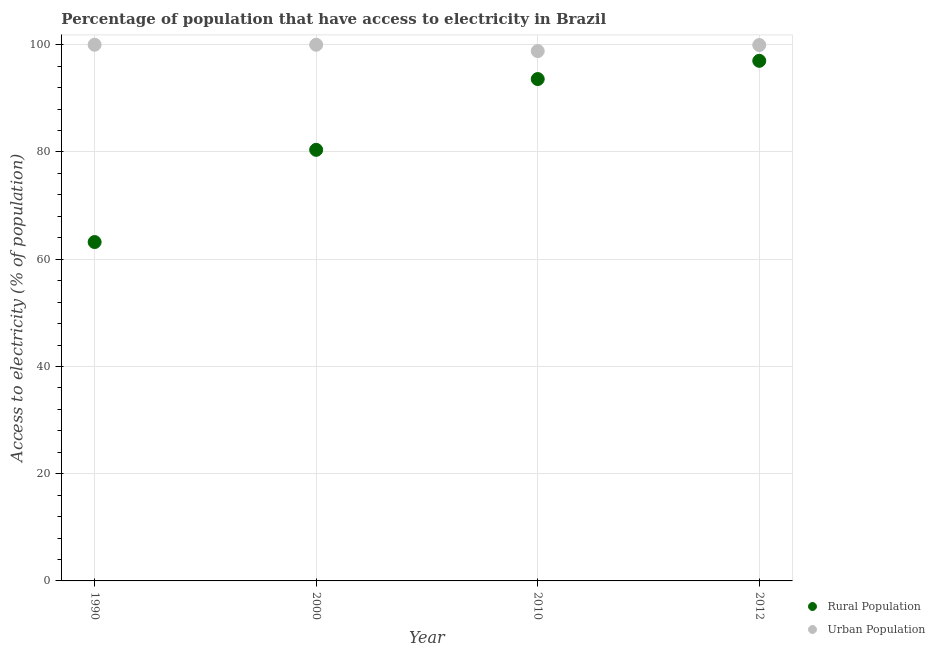How many different coloured dotlines are there?
Provide a succinct answer. 2. Is the number of dotlines equal to the number of legend labels?
Give a very brief answer. Yes. What is the percentage of rural population having access to electricity in 2000?
Your answer should be very brief. 80.4. Across all years, what is the minimum percentage of urban population having access to electricity?
Provide a succinct answer. 98.82. What is the total percentage of urban population having access to electricity in the graph?
Your response must be concise. 398.76. What is the difference between the percentage of urban population having access to electricity in 2000 and that in 2012?
Keep it short and to the point. 0.05. What is the difference between the percentage of rural population having access to electricity in 2010 and the percentage of urban population having access to electricity in 1990?
Give a very brief answer. -6.4. What is the average percentage of rural population having access to electricity per year?
Your response must be concise. 83.55. In the year 2000, what is the difference between the percentage of urban population having access to electricity and percentage of rural population having access to electricity?
Provide a short and direct response. 19.6. In how many years, is the percentage of rural population having access to electricity greater than 76 %?
Ensure brevity in your answer.  3. Is the percentage of urban population having access to electricity in 2000 less than that in 2012?
Make the answer very short. No. Is the difference between the percentage of urban population having access to electricity in 1990 and 2000 greater than the difference between the percentage of rural population having access to electricity in 1990 and 2000?
Make the answer very short. Yes. What is the difference between the highest and the second highest percentage of rural population having access to electricity?
Provide a short and direct response. 3.4. What is the difference between the highest and the lowest percentage of urban population having access to electricity?
Offer a terse response. 1.18. Does the percentage of rural population having access to electricity monotonically increase over the years?
Ensure brevity in your answer.  Yes. Is the percentage of rural population having access to electricity strictly less than the percentage of urban population having access to electricity over the years?
Your answer should be compact. Yes. What is the difference between two consecutive major ticks on the Y-axis?
Ensure brevity in your answer.  20. Are the values on the major ticks of Y-axis written in scientific E-notation?
Your response must be concise. No. Does the graph contain any zero values?
Your answer should be very brief. No. Does the graph contain grids?
Your response must be concise. Yes. Where does the legend appear in the graph?
Provide a succinct answer. Bottom right. How many legend labels are there?
Provide a succinct answer. 2. What is the title of the graph?
Keep it short and to the point. Percentage of population that have access to electricity in Brazil. What is the label or title of the Y-axis?
Ensure brevity in your answer.  Access to electricity (% of population). What is the Access to electricity (% of population) of Rural Population in 1990?
Keep it short and to the point. 63.2. What is the Access to electricity (% of population) of Rural Population in 2000?
Offer a terse response. 80.4. What is the Access to electricity (% of population) in Rural Population in 2010?
Provide a succinct answer. 93.6. What is the Access to electricity (% of population) in Urban Population in 2010?
Keep it short and to the point. 98.82. What is the Access to electricity (% of population) in Rural Population in 2012?
Your response must be concise. 97. What is the Access to electricity (% of population) in Urban Population in 2012?
Give a very brief answer. 99.95. Across all years, what is the maximum Access to electricity (% of population) of Rural Population?
Give a very brief answer. 97. Across all years, what is the maximum Access to electricity (% of population) in Urban Population?
Offer a terse response. 100. Across all years, what is the minimum Access to electricity (% of population) in Rural Population?
Your response must be concise. 63.2. Across all years, what is the minimum Access to electricity (% of population) in Urban Population?
Your answer should be very brief. 98.82. What is the total Access to electricity (% of population) in Rural Population in the graph?
Offer a terse response. 334.2. What is the total Access to electricity (% of population) in Urban Population in the graph?
Ensure brevity in your answer.  398.76. What is the difference between the Access to electricity (% of population) of Rural Population in 1990 and that in 2000?
Your answer should be very brief. -17.2. What is the difference between the Access to electricity (% of population) of Rural Population in 1990 and that in 2010?
Give a very brief answer. -30.4. What is the difference between the Access to electricity (% of population) of Urban Population in 1990 and that in 2010?
Keep it short and to the point. 1.18. What is the difference between the Access to electricity (% of population) of Rural Population in 1990 and that in 2012?
Ensure brevity in your answer.  -33.8. What is the difference between the Access to electricity (% of population) in Urban Population in 1990 and that in 2012?
Your answer should be very brief. 0.05. What is the difference between the Access to electricity (% of population) of Rural Population in 2000 and that in 2010?
Ensure brevity in your answer.  -13.2. What is the difference between the Access to electricity (% of population) of Urban Population in 2000 and that in 2010?
Offer a terse response. 1.18. What is the difference between the Access to electricity (% of population) of Rural Population in 2000 and that in 2012?
Your answer should be very brief. -16.6. What is the difference between the Access to electricity (% of population) in Urban Population in 2000 and that in 2012?
Make the answer very short. 0.05. What is the difference between the Access to electricity (% of population) of Rural Population in 2010 and that in 2012?
Your answer should be very brief. -3.4. What is the difference between the Access to electricity (% of population) of Urban Population in 2010 and that in 2012?
Offer a very short reply. -1.13. What is the difference between the Access to electricity (% of population) in Rural Population in 1990 and the Access to electricity (% of population) in Urban Population in 2000?
Your response must be concise. -36.8. What is the difference between the Access to electricity (% of population) of Rural Population in 1990 and the Access to electricity (% of population) of Urban Population in 2010?
Make the answer very short. -35.62. What is the difference between the Access to electricity (% of population) of Rural Population in 1990 and the Access to electricity (% of population) of Urban Population in 2012?
Your response must be concise. -36.75. What is the difference between the Access to electricity (% of population) of Rural Population in 2000 and the Access to electricity (% of population) of Urban Population in 2010?
Your answer should be compact. -18.42. What is the difference between the Access to electricity (% of population) of Rural Population in 2000 and the Access to electricity (% of population) of Urban Population in 2012?
Offer a very short reply. -19.55. What is the difference between the Access to electricity (% of population) of Rural Population in 2010 and the Access to electricity (% of population) of Urban Population in 2012?
Provide a succinct answer. -6.35. What is the average Access to electricity (% of population) of Rural Population per year?
Provide a succinct answer. 83.55. What is the average Access to electricity (% of population) of Urban Population per year?
Ensure brevity in your answer.  99.69. In the year 1990, what is the difference between the Access to electricity (% of population) of Rural Population and Access to electricity (% of population) of Urban Population?
Give a very brief answer. -36.8. In the year 2000, what is the difference between the Access to electricity (% of population) of Rural Population and Access to electricity (% of population) of Urban Population?
Offer a very short reply. -19.6. In the year 2010, what is the difference between the Access to electricity (% of population) in Rural Population and Access to electricity (% of population) in Urban Population?
Offer a terse response. -5.22. In the year 2012, what is the difference between the Access to electricity (% of population) of Rural Population and Access to electricity (% of population) of Urban Population?
Keep it short and to the point. -2.95. What is the ratio of the Access to electricity (% of population) in Rural Population in 1990 to that in 2000?
Make the answer very short. 0.79. What is the ratio of the Access to electricity (% of population) of Rural Population in 1990 to that in 2010?
Your answer should be very brief. 0.68. What is the ratio of the Access to electricity (% of population) of Rural Population in 1990 to that in 2012?
Your response must be concise. 0.65. What is the ratio of the Access to electricity (% of population) in Urban Population in 1990 to that in 2012?
Offer a very short reply. 1. What is the ratio of the Access to electricity (% of population) of Rural Population in 2000 to that in 2010?
Your answer should be very brief. 0.86. What is the ratio of the Access to electricity (% of population) in Rural Population in 2000 to that in 2012?
Offer a terse response. 0.83. What is the ratio of the Access to electricity (% of population) in Rural Population in 2010 to that in 2012?
Keep it short and to the point. 0.96. What is the ratio of the Access to electricity (% of population) of Urban Population in 2010 to that in 2012?
Your response must be concise. 0.99. What is the difference between the highest and the second highest Access to electricity (% of population) in Rural Population?
Your response must be concise. 3.4. What is the difference between the highest and the second highest Access to electricity (% of population) in Urban Population?
Provide a short and direct response. 0. What is the difference between the highest and the lowest Access to electricity (% of population) of Rural Population?
Make the answer very short. 33.8. What is the difference between the highest and the lowest Access to electricity (% of population) in Urban Population?
Your response must be concise. 1.18. 